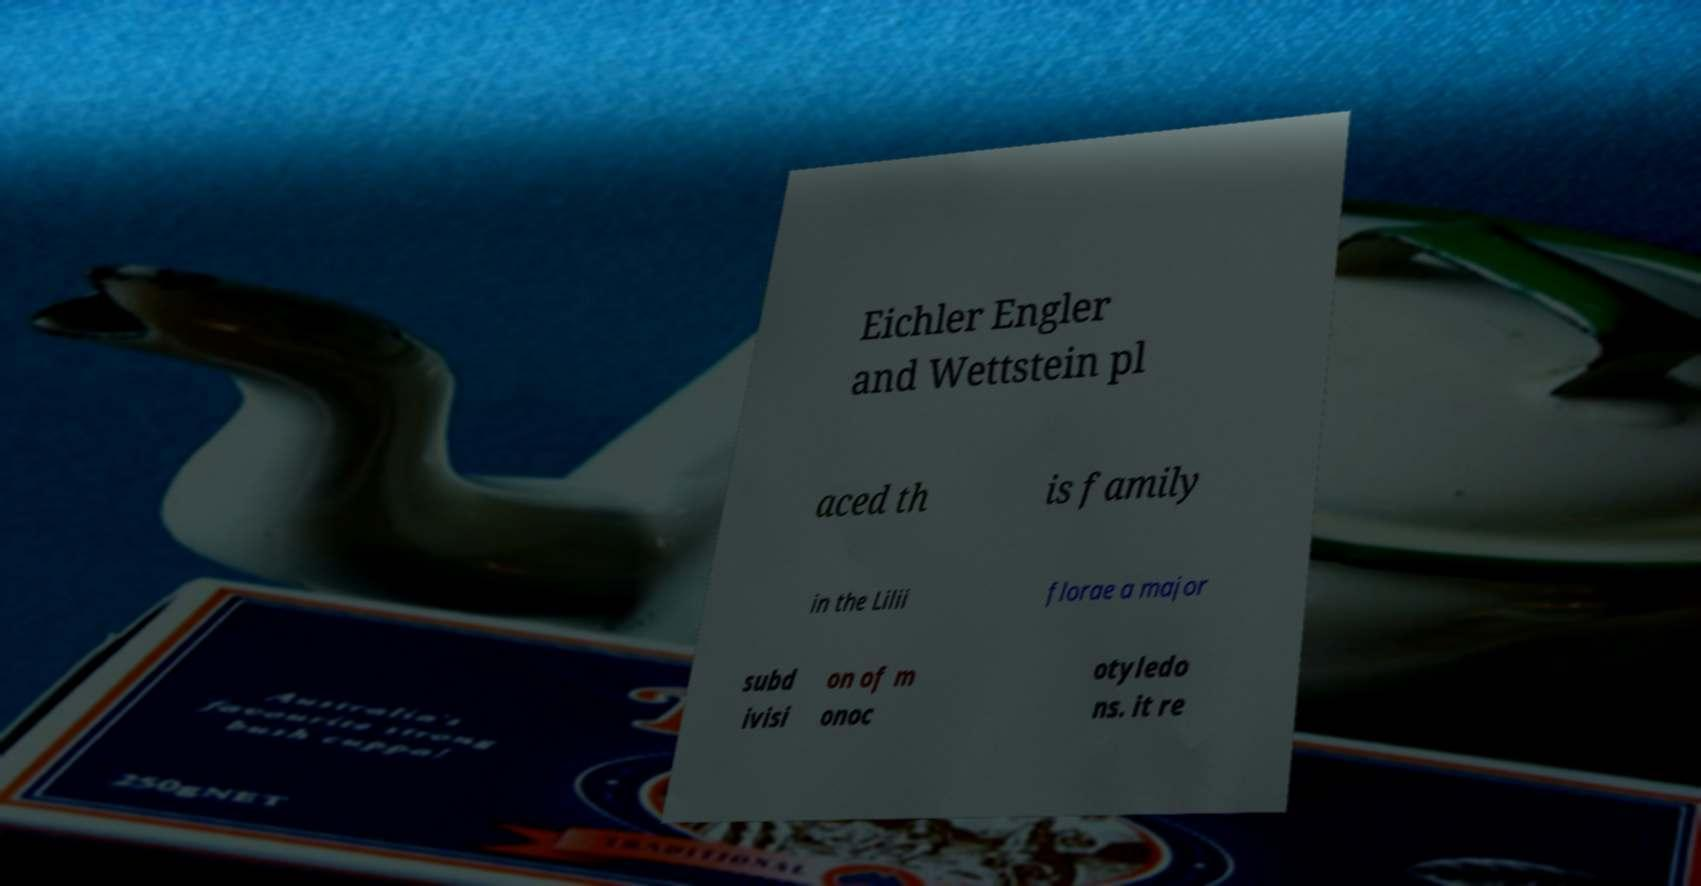For documentation purposes, I need the text within this image transcribed. Could you provide that? Eichler Engler and Wettstein pl aced th is family in the Lilii florae a major subd ivisi on of m onoc otyledo ns. it re 